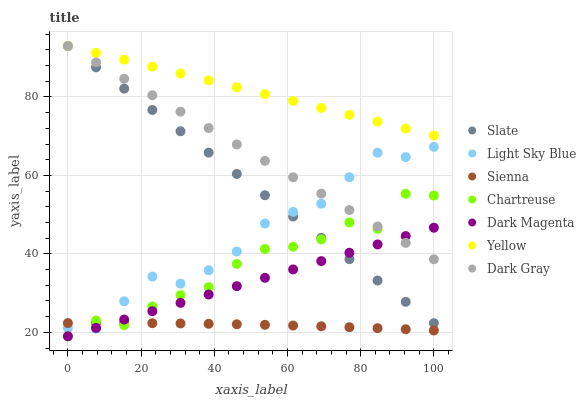Does Sienna have the minimum area under the curve?
Answer yes or no. Yes. Does Yellow have the maximum area under the curve?
Answer yes or no. Yes. Does Dark Magenta have the minimum area under the curve?
Answer yes or no. No. Does Dark Magenta have the maximum area under the curve?
Answer yes or no. No. Is Dark Magenta the smoothest?
Answer yes or no. Yes. Is Chartreuse the roughest?
Answer yes or no. Yes. Is Slate the smoothest?
Answer yes or no. No. Is Slate the roughest?
Answer yes or no. No. Does Dark Magenta have the lowest value?
Answer yes or no. Yes. Does Slate have the lowest value?
Answer yes or no. No. Does Yellow have the highest value?
Answer yes or no. Yes. Does Dark Magenta have the highest value?
Answer yes or no. No. Is Light Sky Blue less than Yellow?
Answer yes or no. Yes. Is Yellow greater than Sienna?
Answer yes or no. Yes. Does Chartreuse intersect Dark Magenta?
Answer yes or no. Yes. Is Chartreuse less than Dark Magenta?
Answer yes or no. No. Is Chartreuse greater than Dark Magenta?
Answer yes or no. No. Does Light Sky Blue intersect Yellow?
Answer yes or no. No. 